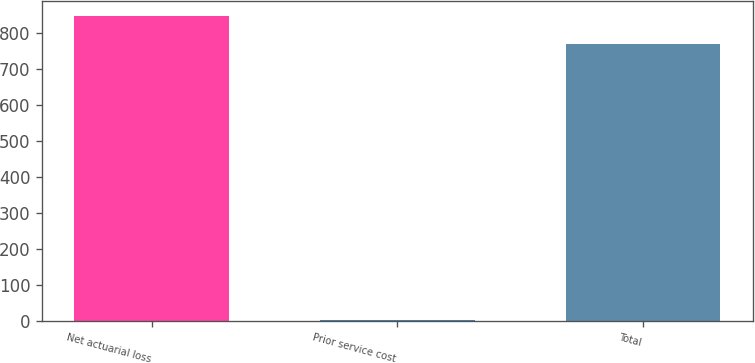Convert chart to OTSL. <chart><loc_0><loc_0><loc_500><loc_500><bar_chart><fcel>Net actuarial loss<fcel>Prior service cost<fcel>Total<nl><fcel>844.87<fcel>1.9<fcel>768.1<nl></chart> 